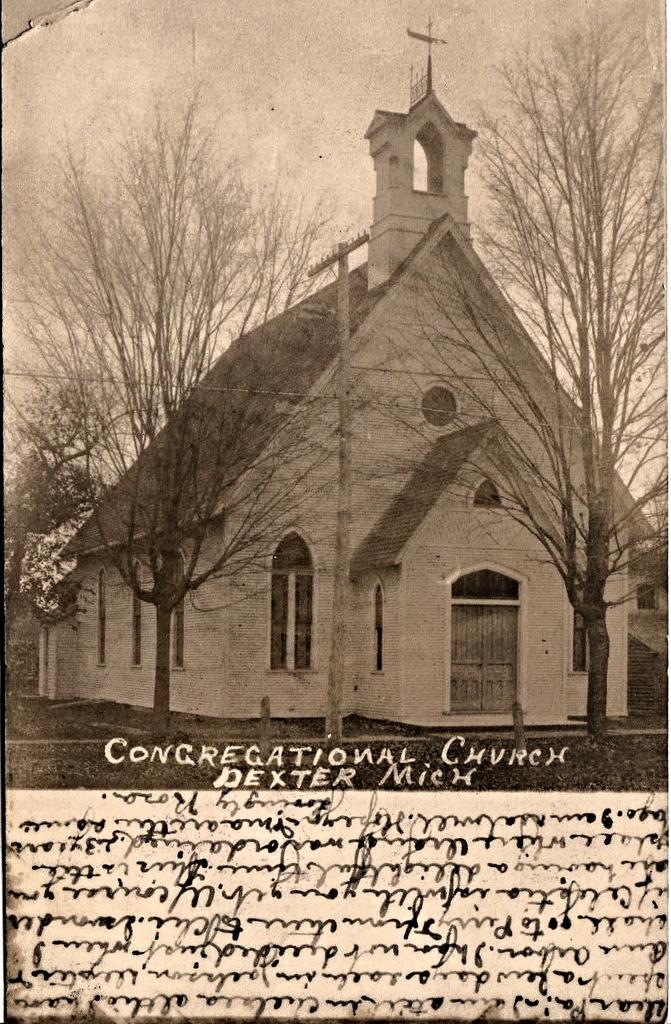Is this a picture of a church?
Make the answer very short. Yes. What state is this in?
Your response must be concise. Michigan. 